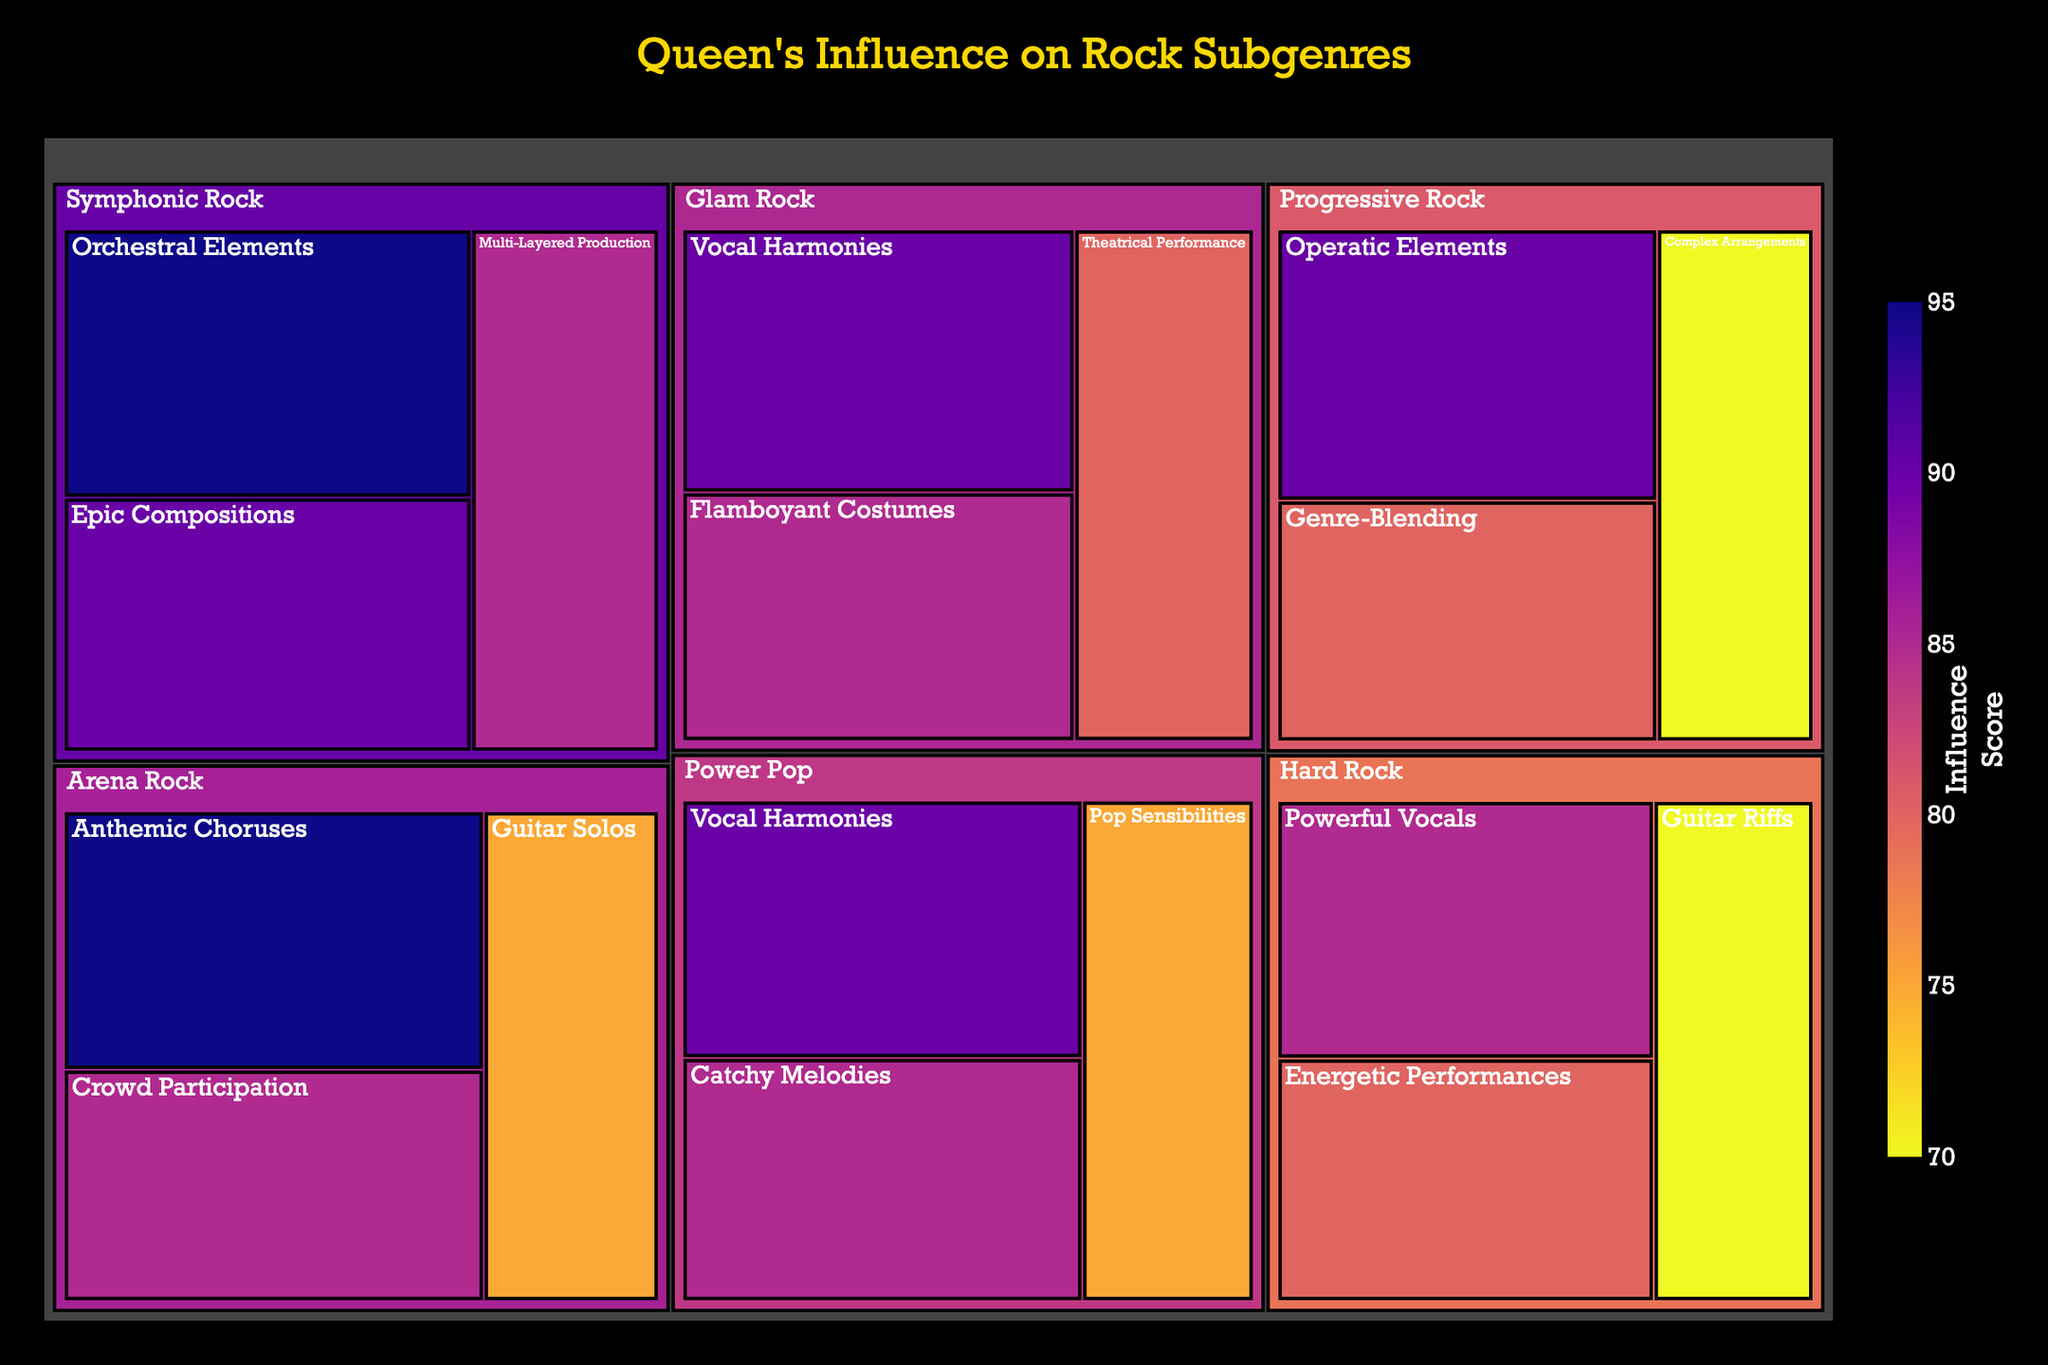What is the title of the treemap? The title is located at the top center of the figure. It reads "Queen's Influence on Rock Subgenres".
Answer: Queen's Influence on Rock Subgenres Which subgenre has the highest influence score for a single musical element? By looking for the subgenre with the highest individual influence score in its elements, "Arena Rock" and "Symphonic Rock" both have elements with the highest score of 95.
Answer: Arena Rock and Symphonic Rock What are the musical elements of Glam Rock influenced by Queen? The treemap shows three musical elements under Glam Rock: Theatrical Performance, Vocal Harmonies, and Flamboyant Costumes.
Answer: Theatrical Performance, Vocal Harmonies, and Flamboyant Costumes What is the total influence score for Symphonic Rock? To find this, sum the influence scores for the elements under Symphonic Rock: 95 (Orchestral Elements) + 90 (Epic Compositions) + 85 (Multi-Layered Production) = 270.
Answer: 270 Which musical element has the second highest influence score in Progressive Rock? Among the elements in Progressive Rock, the scores are 70, 80, and 90. The second highest score is 80 for Genre-Blending.
Answer: Genre-Blending Compare the influence scores of Arena Rock's Guitar Solos and Power Pop's Vocal Harmonies. Which one is higher? Arena Rock's Guitar Solos have a score of 75, and Power Pop's Vocal Harmonies have a score of 90. Therefore, Power Pop's Vocal Harmonies have a higher score.
Answer: Power Pop's Vocal Harmonies What is the average influence score of all musical elements under Hard Rock? Sum the influence scores for Hard Rock: 70 (Guitar Riffs) + 85 (Powerful Vocals) + 80 (Energetic Performances) = 235. Then divide by the number of elements, which is 3. So, 235 / 3 ≈ 78.33.
Answer: 78.33 Which subgenre has more elements influenced by Queen: Power Pop or Arena Rock? Count the number of elements for each subgenre: Power Pop has three (Catchy Melodies, Vocal Harmonies, Pop Sensibilities), and Arena Rock has three (Anthemic Choruses, Guitar Solos, Crowd Participation). Both have the same number of elements.
Answer: Both have the same number What is the influence score difference between Symphonic Rock's Orchestral Elements and Hard Rock's Guitar Riffs? The influence score for Symphonic Rock's Orchestral Elements is 95, and for Hard Rock's Guitar Riffs is 70. The difference is 95 - 70 = 25.
Answer: 25 